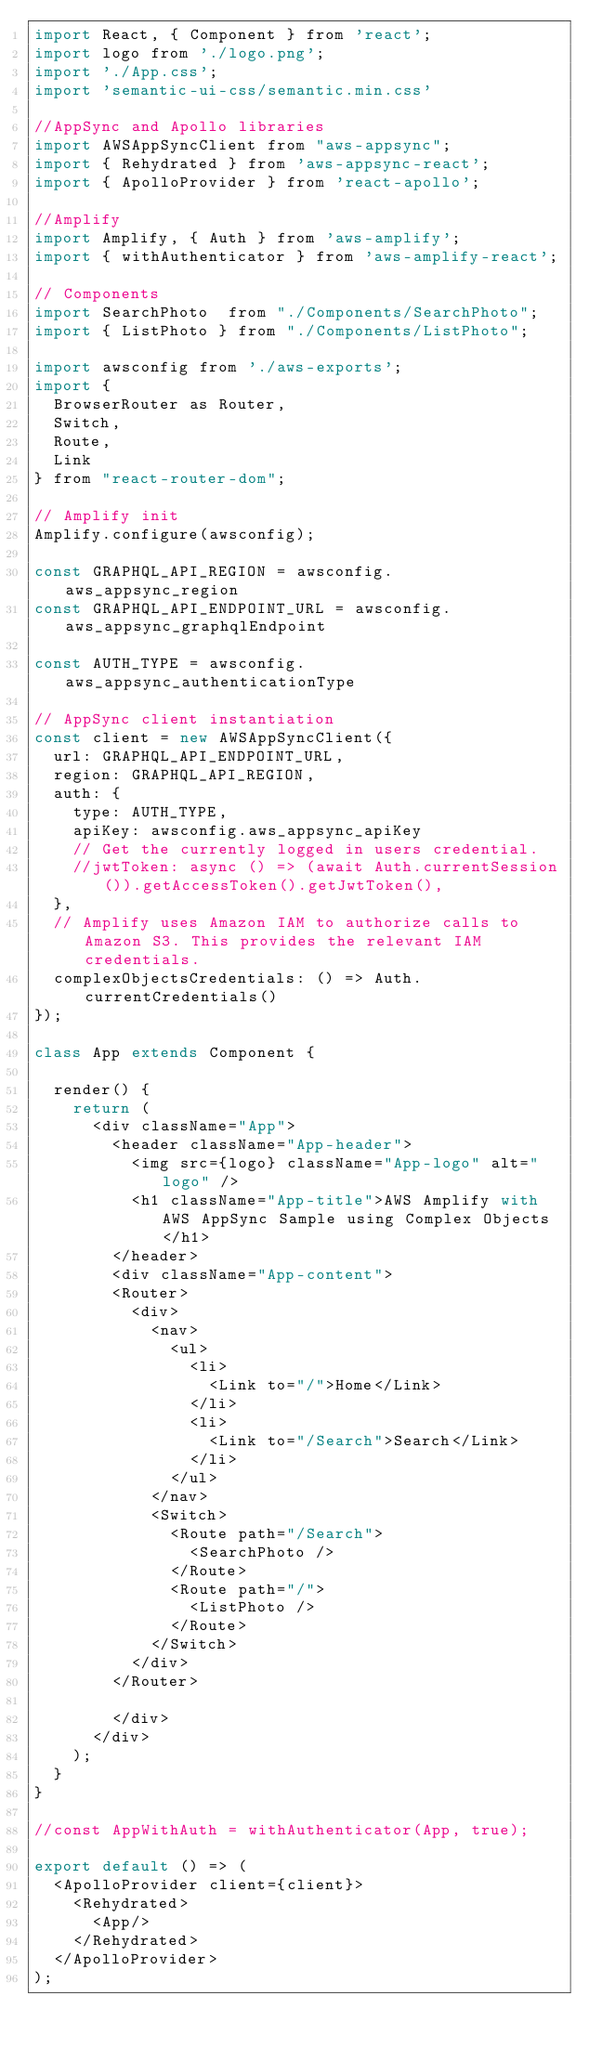Convert code to text. <code><loc_0><loc_0><loc_500><loc_500><_JavaScript_>import React, { Component } from 'react';
import logo from './logo.png';
import './App.css';
import 'semantic-ui-css/semantic.min.css'

//AppSync and Apollo libraries
import AWSAppSyncClient from "aws-appsync";
import { Rehydrated } from 'aws-appsync-react';
import { ApolloProvider } from 'react-apollo';

//Amplify
import Amplify, { Auth } from 'aws-amplify';
import { withAuthenticator } from 'aws-amplify-react';

// Components
import SearchPhoto  from "./Components/SearchPhoto";
import { ListPhoto } from "./Components/ListPhoto";

import awsconfig from './aws-exports';
import {
  BrowserRouter as Router,
  Switch,
  Route,
  Link
} from "react-router-dom";

// Amplify init
Amplify.configure(awsconfig);

const GRAPHQL_API_REGION = awsconfig.aws_appsync_region
const GRAPHQL_API_ENDPOINT_URL = awsconfig.aws_appsync_graphqlEndpoint

const AUTH_TYPE = awsconfig.aws_appsync_authenticationType

// AppSync client instantiation
const client = new AWSAppSyncClient({
  url: GRAPHQL_API_ENDPOINT_URL,
  region: GRAPHQL_API_REGION,
  auth: {
    type: AUTH_TYPE,
    apiKey: awsconfig.aws_appsync_apiKey
    // Get the currently logged in users credential.
    //jwtToken: async () => (await Auth.currentSession()).getAccessToken().getJwtToken(),
  },
  // Amplify uses Amazon IAM to authorize calls to Amazon S3. This provides the relevant IAM credentials.
  complexObjectsCredentials: () => Auth.currentCredentials()
});

class App extends Component {

  render() {
    return (
      <div className="App">
        <header className="App-header">
          <img src={logo} className="App-logo" alt="logo" />
          <h1 className="App-title">AWS Amplify with AWS AppSync Sample using Complex Objects </h1>
        </header>
        <div className="App-content">
        <Router>
          <div>
            <nav>
              <ul>
                <li>
                  <Link to="/">Home</Link>
                </li>
                <li>
                  <Link to="/Search">Search</Link>
                </li>
              </ul>
            </nav>
            <Switch>
              <Route path="/Search">
                <SearchPhoto />
              </Route>
              <Route path="/">
                <ListPhoto />
              </Route>
            </Switch>
          </div>
        </Router>

        </div>
      </div>
    );
  }
}

//const AppWithAuth = withAuthenticator(App, true);

export default () => (
  <ApolloProvider client={client}>
    <Rehydrated>
      <App/>
    </Rehydrated>
  </ApolloProvider>
);
</code> 